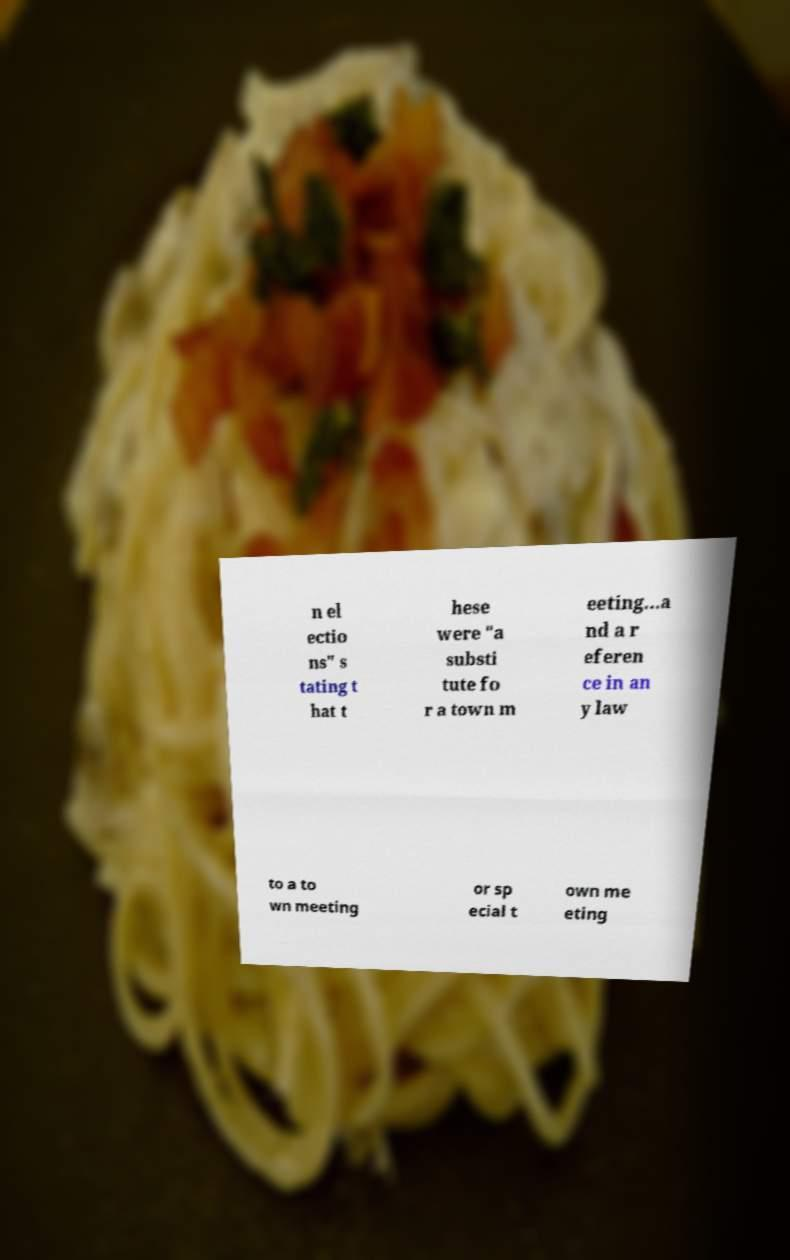Could you assist in decoding the text presented in this image and type it out clearly? n el ectio ns" s tating t hat t hese were "a substi tute fo r a town m eeting...a nd a r eferen ce in an y law to a to wn meeting or sp ecial t own me eting 